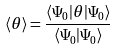<formula> <loc_0><loc_0><loc_500><loc_500>\langle \theta \rangle = \frac { \langle \Psi _ { 0 } | \theta | \Psi _ { 0 } \rangle } { \langle \Psi _ { 0 } | \Psi _ { 0 } \rangle }</formula> 